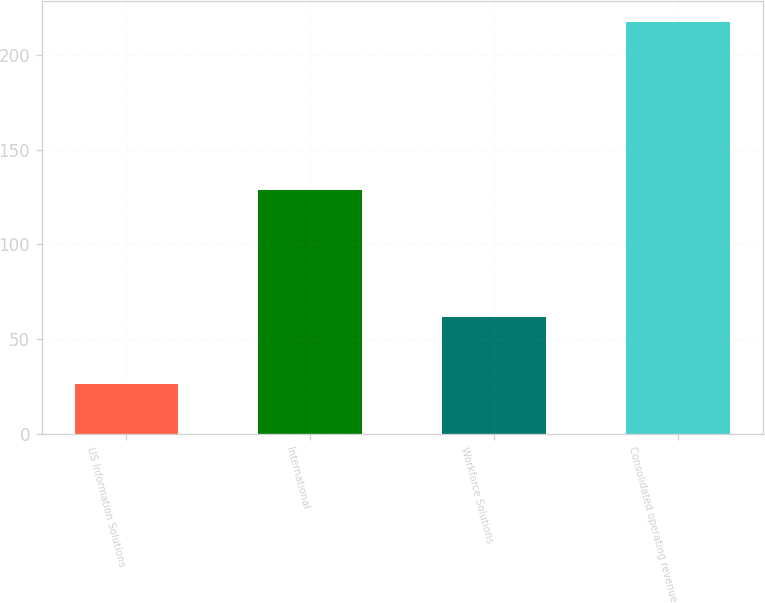Convert chart to OTSL. <chart><loc_0><loc_0><loc_500><loc_500><bar_chart><fcel>US Information Solutions<fcel>International<fcel>Workforce Solutions<fcel>Consolidated operating revenue<nl><fcel>26.2<fcel>128.7<fcel>62<fcel>217.3<nl></chart> 